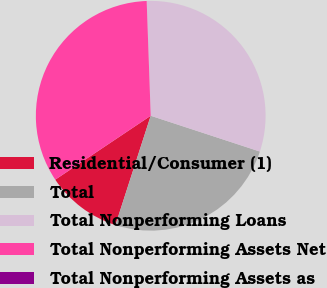Convert chart. <chart><loc_0><loc_0><loc_500><loc_500><pie_chart><fcel>Residential/Consumer (1)<fcel>Total<fcel>Total Nonperforming Loans<fcel>Total Nonperforming Assets Net<fcel>Total Nonperforming Assets as<nl><fcel>10.64%<fcel>24.93%<fcel>30.6%<fcel>33.83%<fcel>0.0%<nl></chart> 